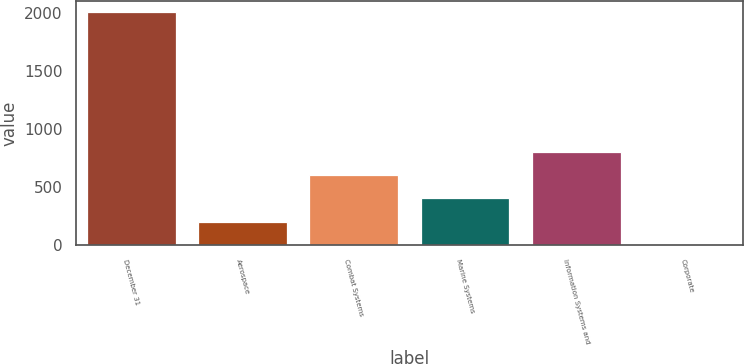<chart> <loc_0><loc_0><loc_500><loc_500><bar_chart><fcel>December 31<fcel>Aerospace<fcel>Combat Systems<fcel>Marine Systems<fcel>Information Systems and<fcel>Corporate<nl><fcel>2005<fcel>205<fcel>605<fcel>405<fcel>805<fcel>5<nl></chart> 